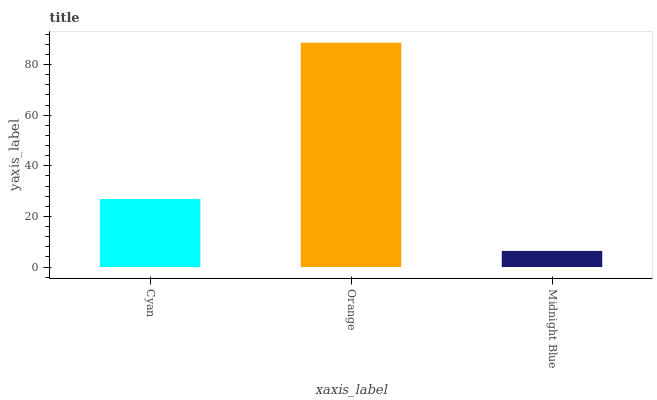Is Midnight Blue the minimum?
Answer yes or no. Yes. Is Orange the maximum?
Answer yes or no. Yes. Is Orange the minimum?
Answer yes or no. No. Is Midnight Blue the maximum?
Answer yes or no. No. Is Orange greater than Midnight Blue?
Answer yes or no. Yes. Is Midnight Blue less than Orange?
Answer yes or no. Yes. Is Midnight Blue greater than Orange?
Answer yes or no. No. Is Orange less than Midnight Blue?
Answer yes or no. No. Is Cyan the high median?
Answer yes or no. Yes. Is Cyan the low median?
Answer yes or no. Yes. Is Orange the high median?
Answer yes or no. No. Is Midnight Blue the low median?
Answer yes or no. No. 